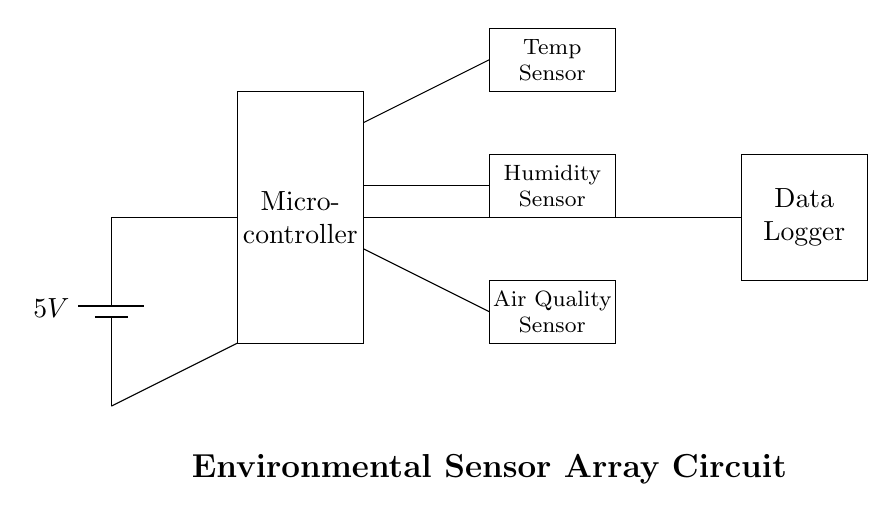What voltage is supplied to the circuit? The circuit is powered by a battery that provides a voltage of 5V, as indicated by the label next to the battery symbol.
Answer: 5V What components are used in this circuit? The circuit includes a microcontroller, a temperature sensor, a humidity sensor, an air quality sensor, and a data logger. Each component is represented by a labeled rectangle in the diagram.
Answer: Microcontroller, Temperature Sensor, Humidity Sensor, Air Quality Sensor, Data Logger How many sensors are present in the circuit? There are three sensors in the circuit: a temperature sensor, a humidity sensor, and an air quality sensor. Each sensor has its own distinct rectangle.
Answer: Three What is the purpose of the microcontroller in this circuit? The microcontroller processes data from the sensors and likely controls the data logger to store or transmit the collected environmental data. Its role is central in interfacing with the sensors and managing data flow.
Answer: Data processing What connections are made to the data logger? The data logger is connected to the output of the microcontroller, receiving processed data from all three sensors. This connection is facilitated by a direct line that indicates data flow from the microcontroller output.
Answer: Direct connection Which sensor is situated at the lowest position within the circuit? The air quality sensor is located at the lowest position in the circuit diagram, as indicated by its rectangle being lower than the other sensor rectangles.
Answer: Air Quality Sensor 